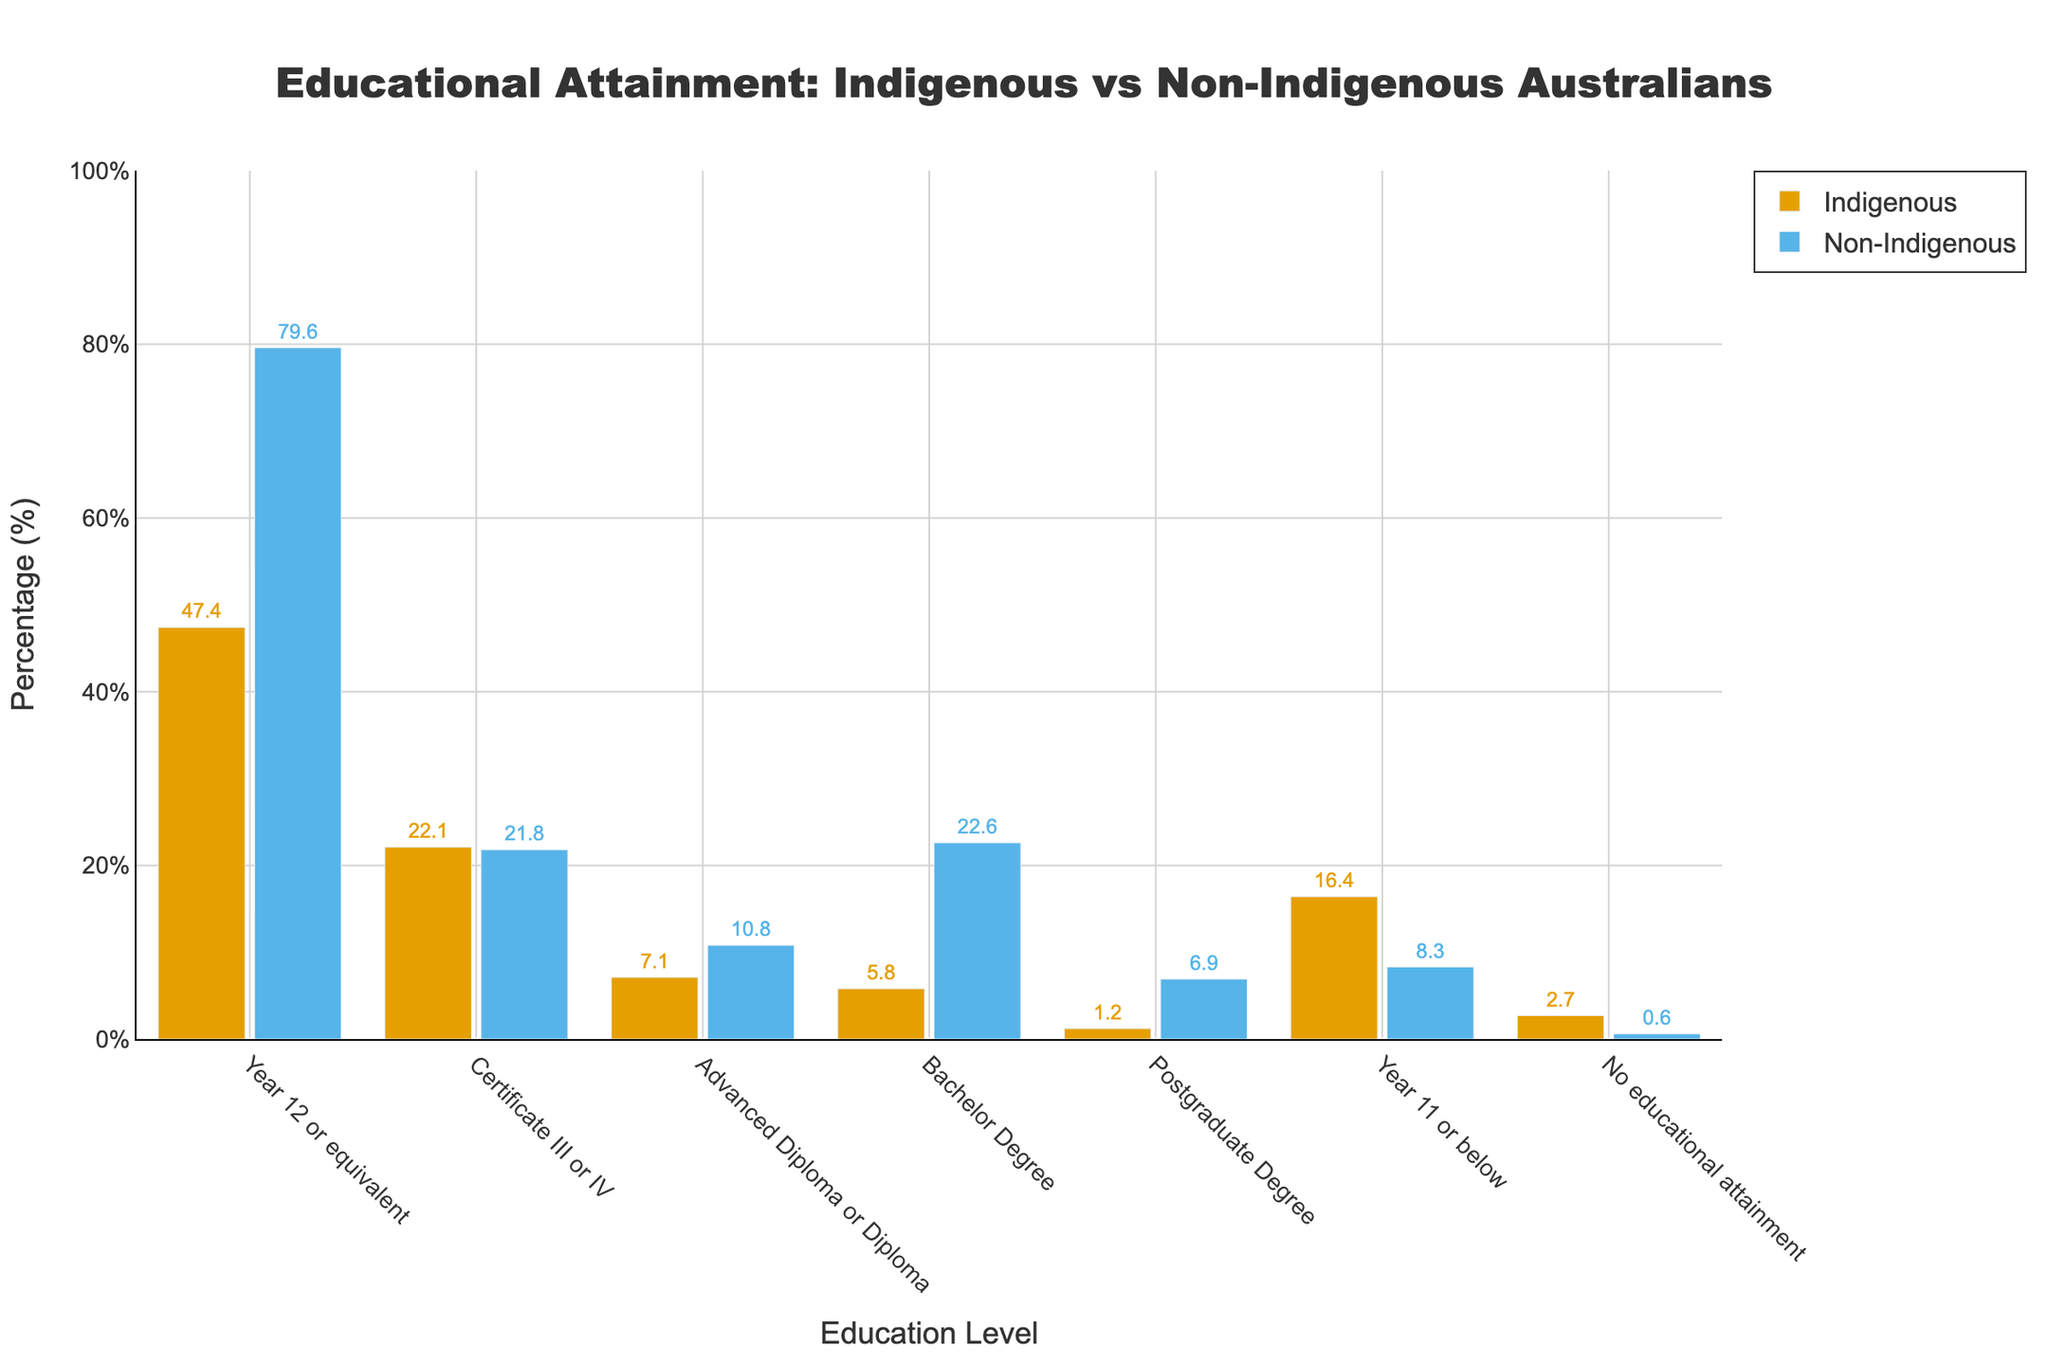What percentage of Indigenous Australians attained Year 12 or equivalent education? The figure shows that the bar corresponding to Indigenous Australians for the ‘Year 12 or equivalent’ category reaches 47.4%.
Answer: 47.4% Which group has a higher percentage of Bachelor Degree holders? Compare the heights of the bars corresponding to ‘Bachelor Degree’ for both Indigenous and Non-Indigenous Australians; the Non-Indigenous bar is taller, showing 22.6%, while the Indigenous bar shows 5.8%. Thus, Non-Indigenous Australians have a higher percentage.
Answer: Non-Indigenous What is the difference in the percentage of individuals with no educational attainment between Indigenous and Non-Indigenous Australians? From the figure, the ‘No educational attainment’ bar for Indigenous Australians is 2.7%, while for Non-Indigenous Australians it is 0.6%. The difference is 2.7% - 0.6% = 2.1%.
Answer: 2.1% How do the percentages compare for those with a Postgraduate Degree between Indigenous and Non-Indigenous Australians? The bars for the Postgraduate Degree show that Indigenous Australians have 1.2%, while Non-Indigenous Australians have 6.9%. Non-Indigenous Australians have a significantly higher percentage.
Answer: Non-Indigenous have higher What is the combined percentage of Indigenous Australians with Year 12 or equivalent, Certificate III or IV, and a Bachelor Degree? Add the percentages for these categories: 47.4% (Year 12) + 22.1% (Certificate III or IV) + 5.8% (Bachelor) = 75.3%.
Answer: 75.3% Which educational category has the closest percentage between Indigenous and Non-Indigenous Australians? Compare the bars' heights across all categories; the ‘Certificate III or IV’ category shows the closest values: 22.1% for Indigenous and 21.8% for Non-Indigenous Australians, a difference of only 0.3%.
Answer: Certificate III or IV In which category is the percentage of Non-Indigenous Australians more than twice that of Indigenous Australians? Comparing the bars, in the ‘Bachelor Degree’ category, Non-Indigenous Australians have 22.6%, and Indigenous Australians have 5.8%, which is more than double (5.8% * 2 = 11.6%). Similarly, the ‘Postgraduate Degree’ category also shows this trend with Non-Indigenous Australians having 6.9% and Indigenous Australians 1.2% (1.2% * 2 = 2.4%).
Answer: Bachelor Degree and Postgraduate Degree Which group has a wider range of educational attainment percentages? The widest range is determined by the difference between the highest and lowest values. Indigenous Australians range from 47.4% (Year 12) to 1.2% (Postgraduate Degree), giving a range of 46.2%. Non-Indigenous Australians range from 79.6% (Year 12) to 0.6% (No educational attainment), giving a range of 79%. Thus, Non-Indigenous Australians have a wider range.
Answer: Non-Indigenous 